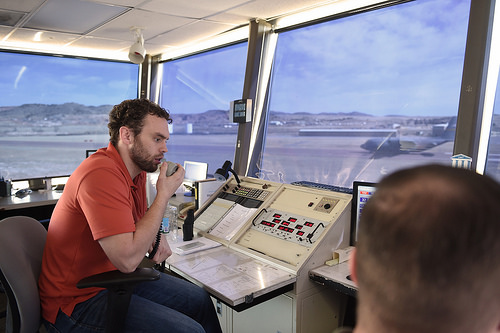<image>
Can you confirm if the man is next to the plane? No. The man is not positioned next to the plane. They are located in different areas of the scene. 